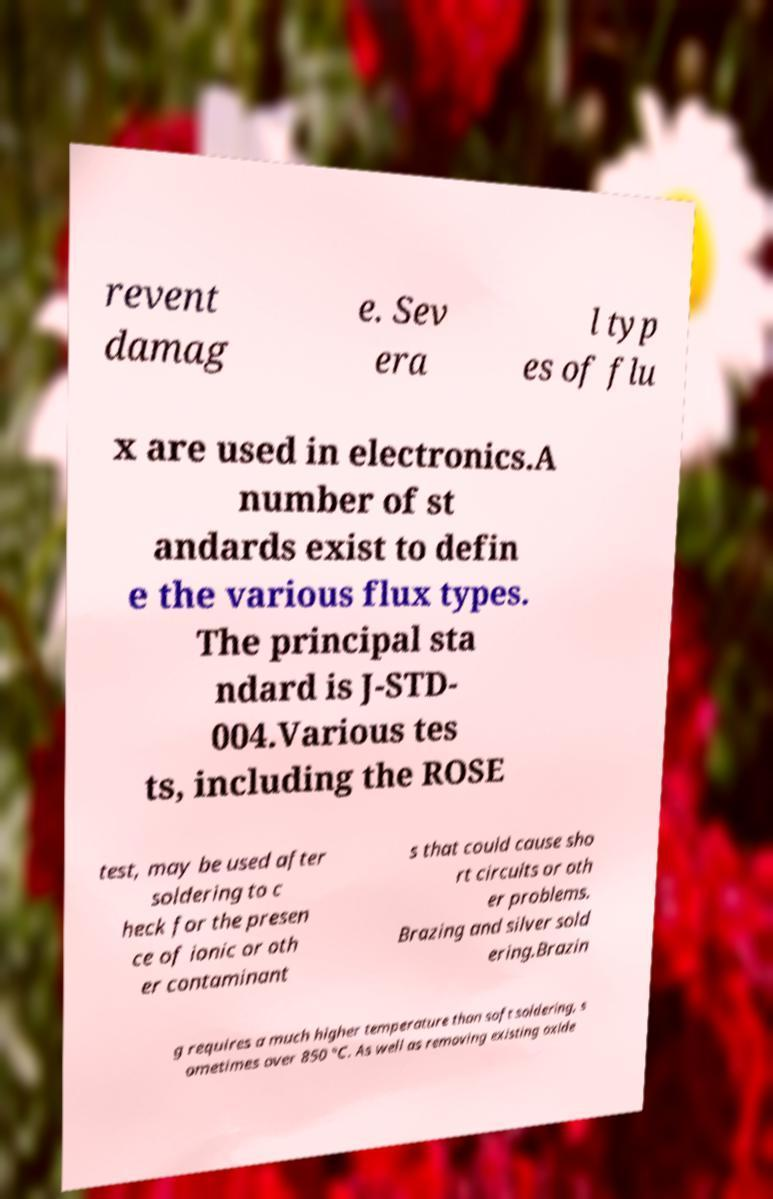Can you accurately transcribe the text from the provided image for me? revent damag e. Sev era l typ es of flu x are used in electronics.A number of st andards exist to defin e the various flux types. The principal sta ndard is J-STD- 004.Various tes ts, including the ROSE test, may be used after soldering to c heck for the presen ce of ionic or oth er contaminant s that could cause sho rt circuits or oth er problems. Brazing and silver sold ering.Brazin g requires a much higher temperature than soft soldering, s ometimes over 850 °C. As well as removing existing oxide 